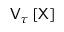Convert formula to latex. <formula><loc_0><loc_0><loc_500><loc_500>V _ { \tau } \left [ X \right ]</formula> 